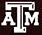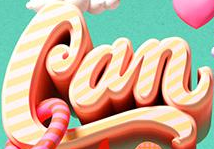Read the text content from these images in order, separated by a semicolon. ATM; Can 